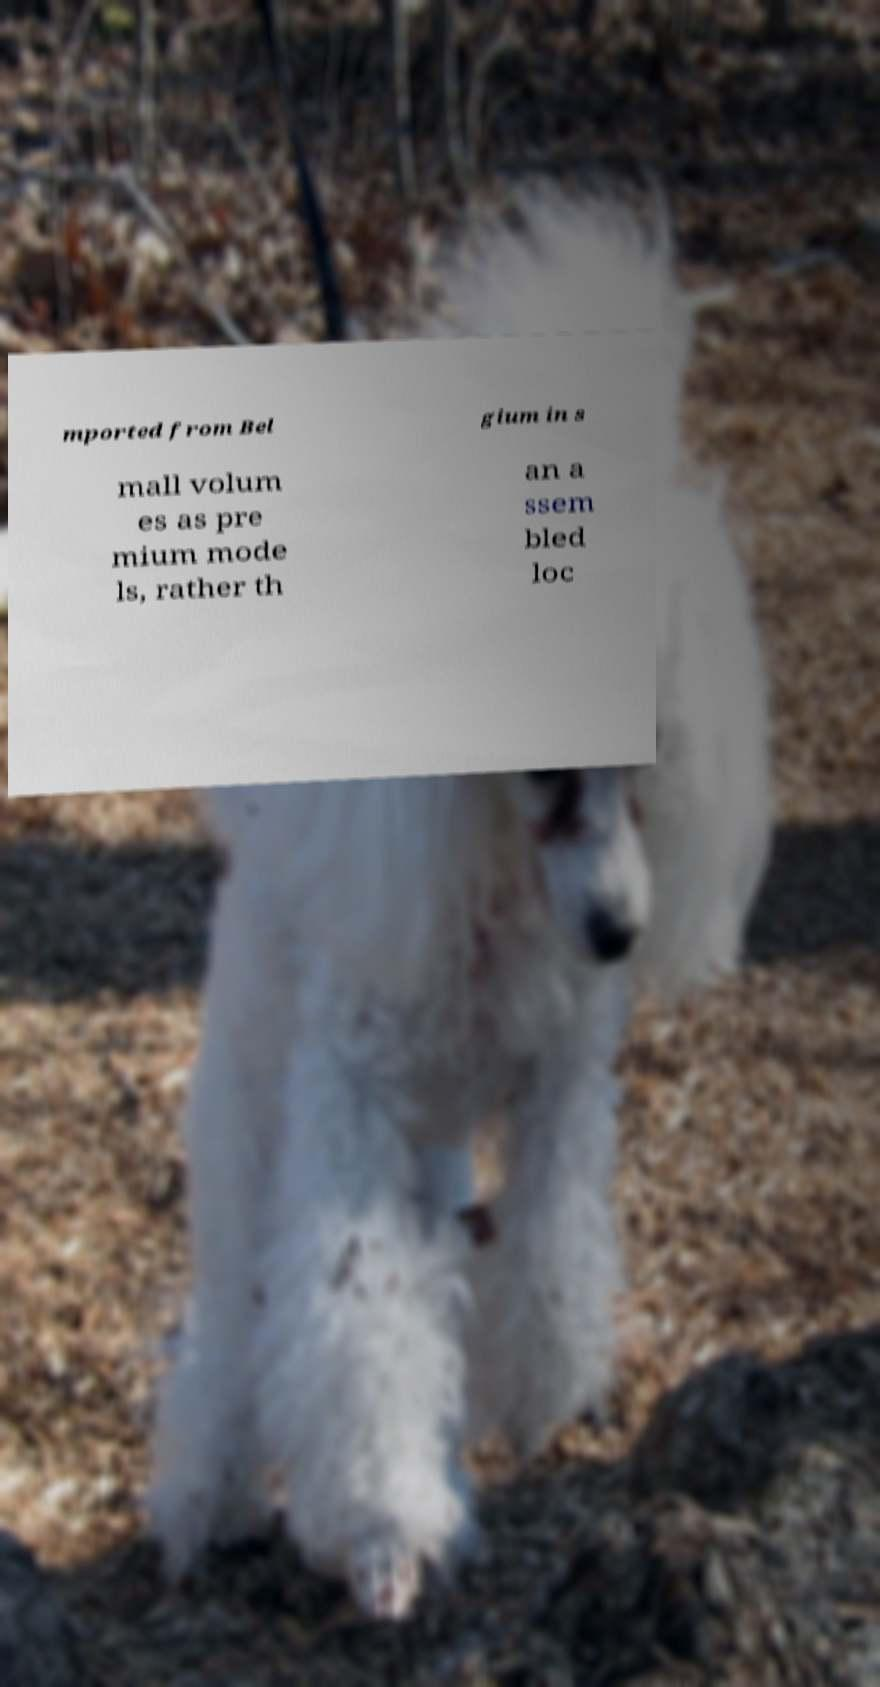There's text embedded in this image that I need extracted. Can you transcribe it verbatim? mported from Bel gium in s mall volum es as pre mium mode ls, rather th an a ssem bled loc 